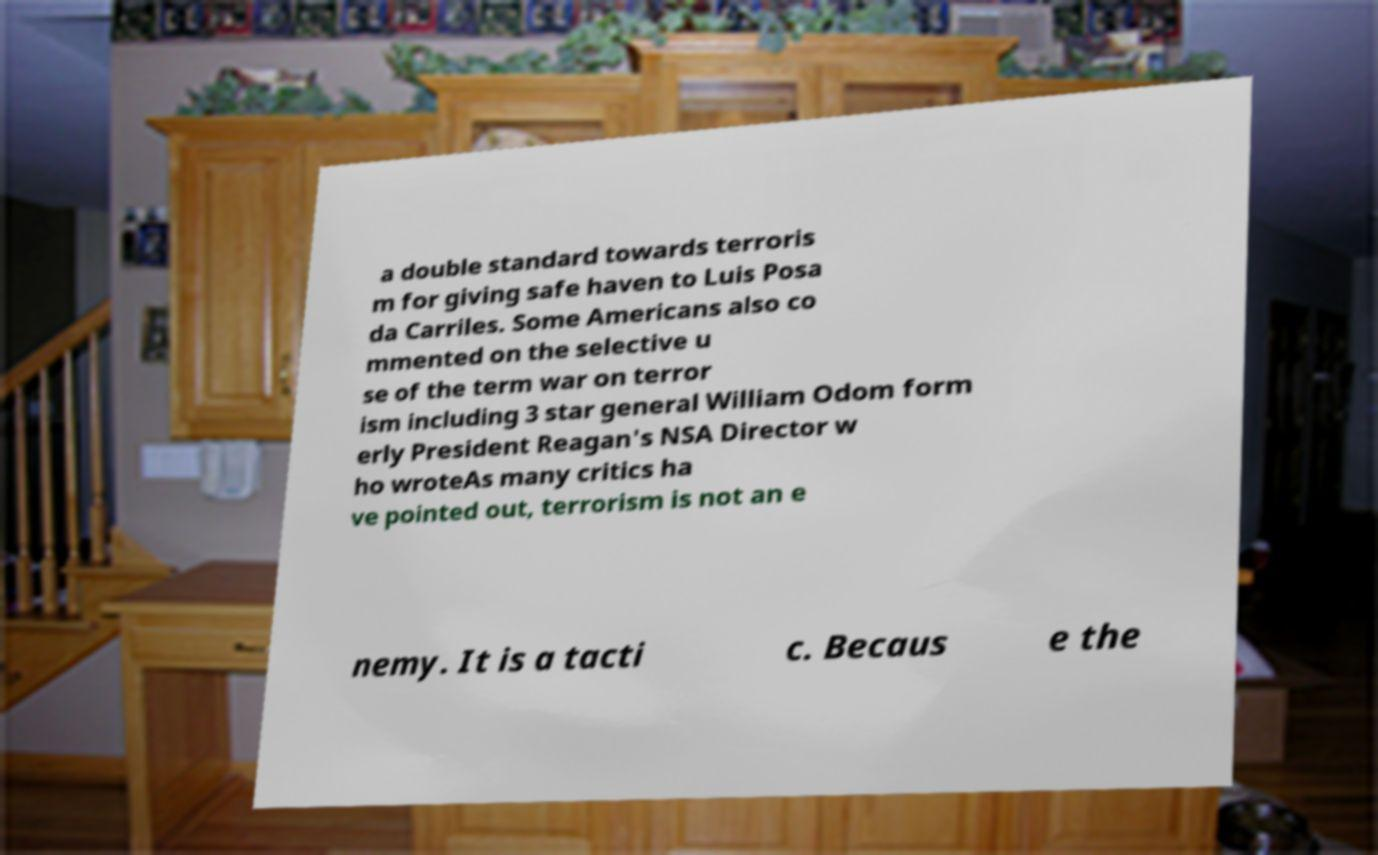What messages or text are displayed in this image? I need them in a readable, typed format. a double standard towards terroris m for giving safe haven to Luis Posa da Carriles. Some Americans also co mmented on the selective u se of the term war on terror ism including 3 star general William Odom form erly President Reagan's NSA Director w ho wroteAs many critics ha ve pointed out, terrorism is not an e nemy. It is a tacti c. Becaus e the 